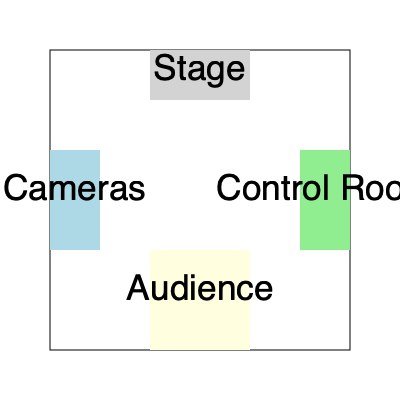As a Spanish television show critic, you're reviewing the layout of a new studio for a popular talk show. Given the floor plan above, which area would you recommend for the audience seating to ensure optimal viewing and engagement with the show? To determine the best placement for audience seating, we need to consider several factors:

1. Visibility of the stage: The audience should have a clear view of the stage where the main action takes place.
2. Interaction with the host and guests: The seating should allow for easy interaction between the audience and the show's participants.
3. Camera angles: The audience should be positioned in a way that allows for good camera shots without obstruction.
4. Technical considerations: The seating should not interfere with the technical aspects of the production.

Analyzing the floor plan:

1. The stage is located at the top of the diagram, which is typically the focal point of a television studio.
2. The cameras are positioned on the left side, facing the stage.
3. The control room is on the right side, away from the main action.
4. There's a designated area at the bottom of the diagram labeled "Audience."

Given this layout:

1. The audience area at the bottom provides the best view of the stage, as it's directly opposite it.
2. This position allows for easy interaction with the host and guests on stage.
3. The cameras on the left can capture both the stage and the audience reactions without obstruction.
4. The audience is far enough from the control room to avoid interference with technical operations.

Therefore, the area labeled "Audience" in the bottom center of the floor plan is the optimal location for seating.
Answer: Bottom center (labeled "Audience") 